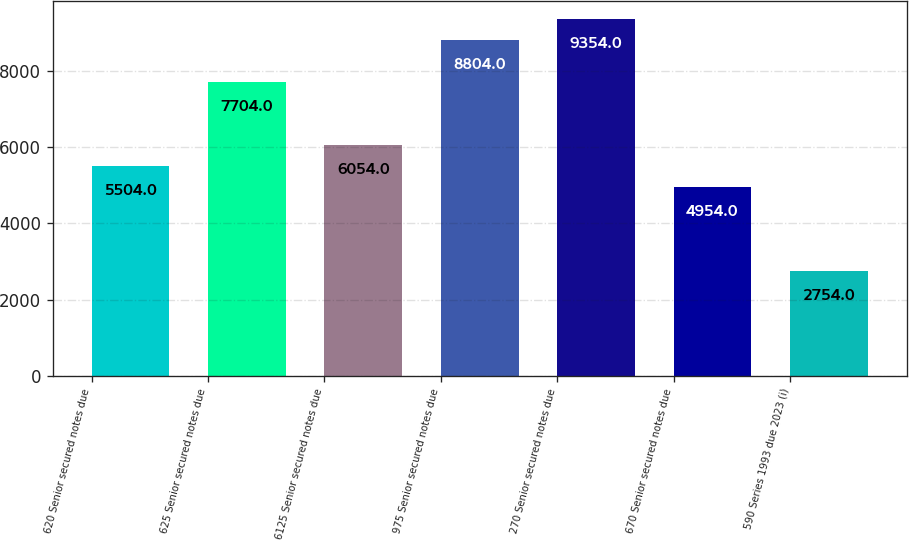<chart> <loc_0><loc_0><loc_500><loc_500><bar_chart><fcel>620 Senior secured notes due<fcel>625 Senior secured notes due<fcel>6125 Senior secured notes due<fcel>975 Senior secured notes due<fcel>270 Senior secured notes due<fcel>670 Senior secured notes due<fcel>590 Series 1993 due 2023 (i)<nl><fcel>5504<fcel>7704<fcel>6054<fcel>8804<fcel>9354<fcel>4954<fcel>2754<nl></chart> 